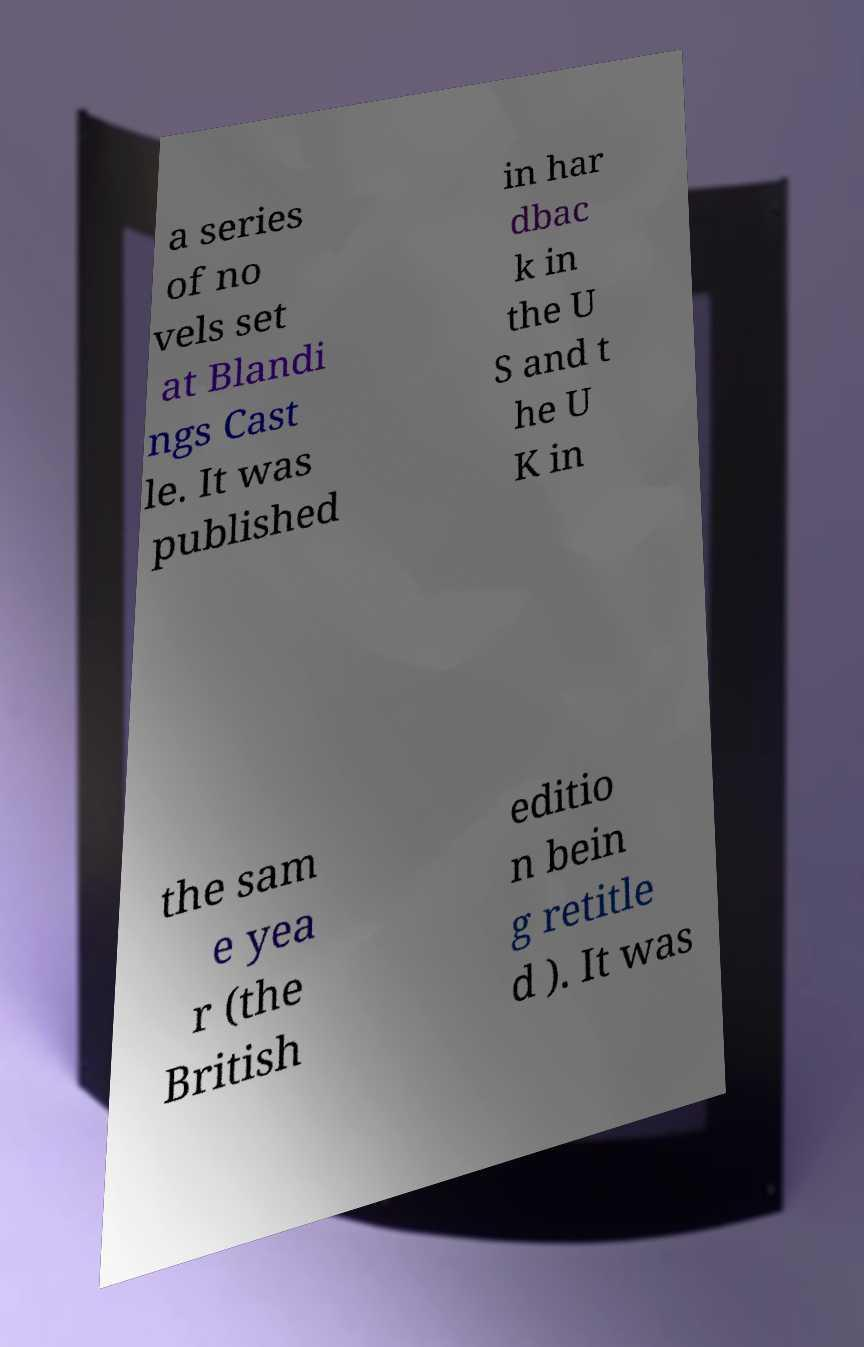For documentation purposes, I need the text within this image transcribed. Could you provide that? a series of no vels set at Blandi ngs Cast le. It was published in har dbac k in the U S and t he U K in the sam e yea r (the British editio n bein g retitle d ). It was 